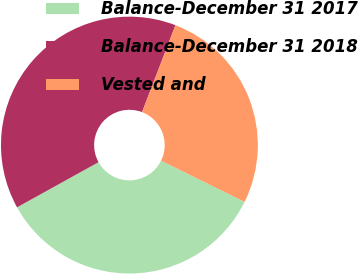Convert chart to OTSL. <chart><loc_0><loc_0><loc_500><loc_500><pie_chart><fcel>Balance-December 31 2017<fcel>Balance-December 31 2018<fcel>Vested and<nl><fcel>34.66%<fcel>38.89%<fcel>26.45%<nl></chart> 